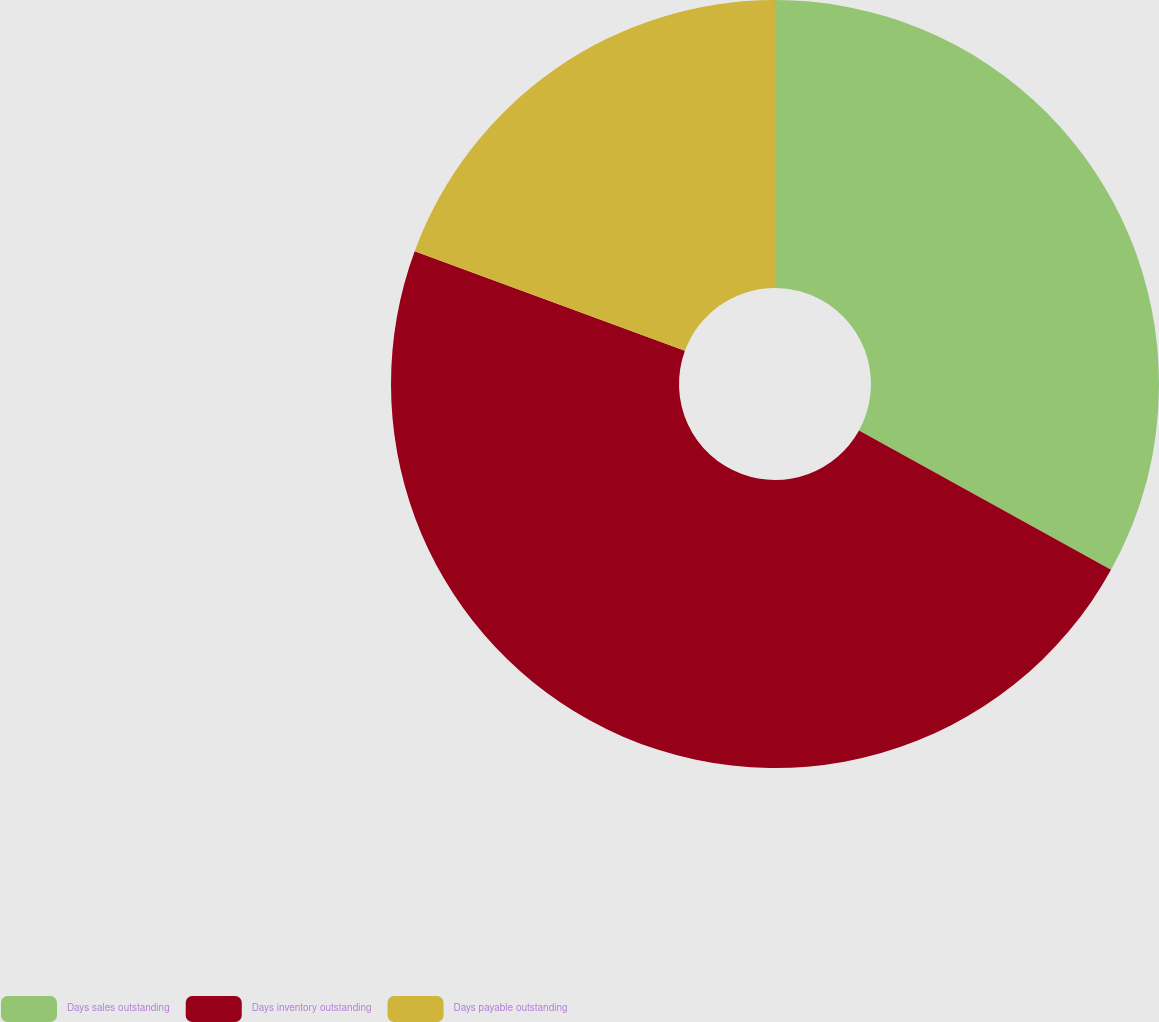<chart> <loc_0><loc_0><loc_500><loc_500><pie_chart><fcel>Days sales outstanding<fcel>Days inventory outstanding<fcel>Days payable outstanding<nl><fcel>33.04%<fcel>47.58%<fcel>19.38%<nl></chart> 